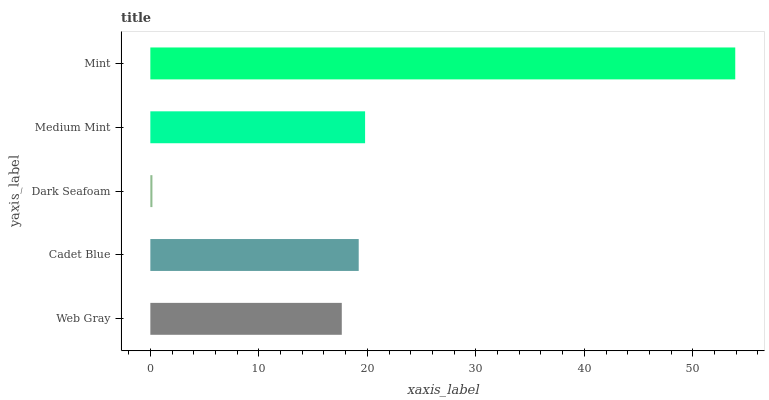Is Dark Seafoam the minimum?
Answer yes or no. Yes. Is Mint the maximum?
Answer yes or no. Yes. Is Cadet Blue the minimum?
Answer yes or no. No. Is Cadet Blue the maximum?
Answer yes or no. No. Is Cadet Blue greater than Web Gray?
Answer yes or no. Yes. Is Web Gray less than Cadet Blue?
Answer yes or no. Yes. Is Web Gray greater than Cadet Blue?
Answer yes or no. No. Is Cadet Blue less than Web Gray?
Answer yes or no. No. Is Cadet Blue the high median?
Answer yes or no. Yes. Is Cadet Blue the low median?
Answer yes or no. Yes. Is Mint the high median?
Answer yes or no. No. Is Medium Mint the low median?
Answer yes or no. No. 